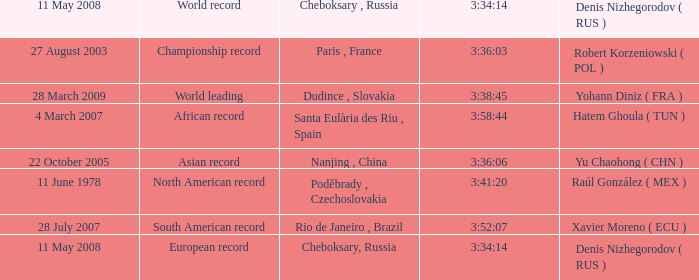When 3:41:20 is  3:34:14 what is cheboksary , russia? Poděbrady , Czechoslovakia. 